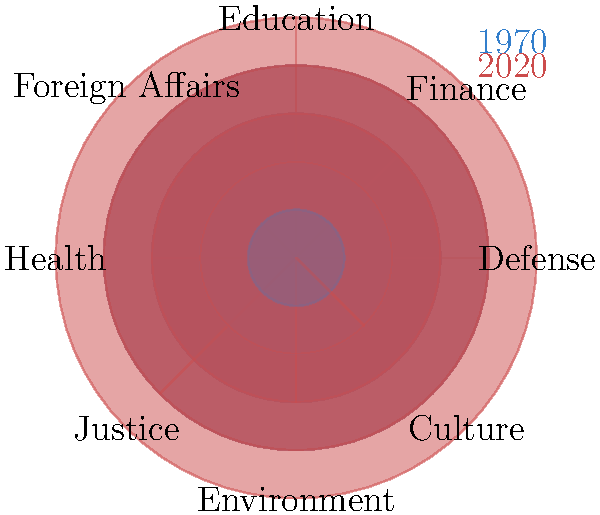Based on the polar area diagram representing the budget allocation across different Swedish ministries in 1970 and 2020, which ministry shows the most significant relative increase in budget allocation over this 50-year period? To determine which ministry has shown the most significant relative increase in budget allocation from 1970 to 2020, we need to compare the areas of the sectors for each ministry between the two years. The steps are as follows:

1. Identify the ministries: Defense, Finance, Education, Foreign Affairs, Health, Justice, Environment, and Culture.

2. Compare the areas of the 1970 (blue) and 2020 (red) sectors for each ministry:
   - Defense: Moderate increase
   - Finance: Significant increase
   - Education: Moderate increase
   - Foreign Affairs: Significant increase
   - Health: Significant increase
   - Justice: Moderate increase
   - Environment: Significant increase
   - Culture: Significant increase

3. Assess the relative increase:
   While several ministries show significant increases, we need to consider the relative change. The ministry with the smallest sector in 1970 that grew to a much larger sector in 2020 would represent the most significant relative increase.

4. Identify the ministry with the smallest 1970 sector that grew significantly:
   Foreign Affairs and Culture had the smallest sectors in 1970, but Culture shows a more substantial growth relative to its initial size.

5. Conclusion:
   The Culture ministry appears to have the most significant relative increase in budget allocation from 1970 to 2020.
Answer: Culture ministry 